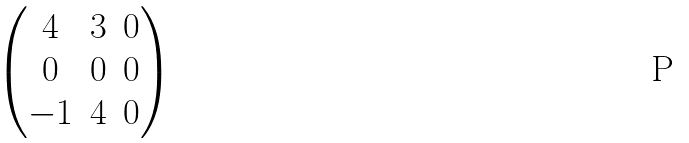<formula> <loc_0><loc_0><loc_500><loc_500>\begin{pmatrix} 4 & 3 & 0 \\ 0 & 0 & 0 \\ - 1 & 4 & 0 \\ \end{pmatrix}</formula> 